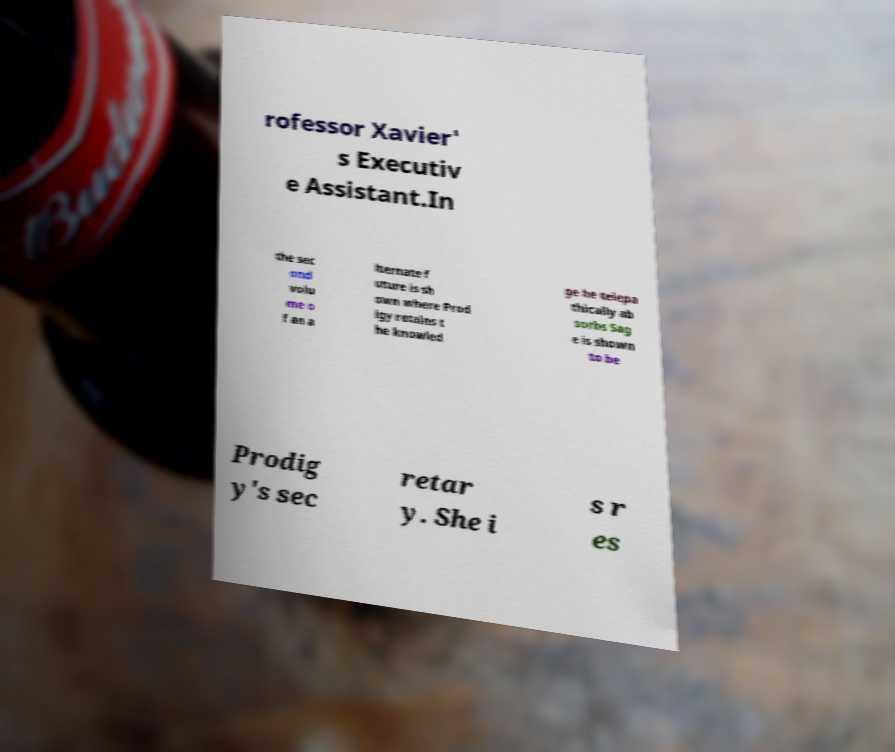I need the written content from this picture converted into text. Can you do that? rofessor Xavier' s Executiv e Assistant.In the sec ond volu me o f an a lternate f uture is sh own where Prod igy retains t he knowled ge he telepa thically ab sorbs Sag e is shown to be Prodig y's sec retar y. She i s r es 